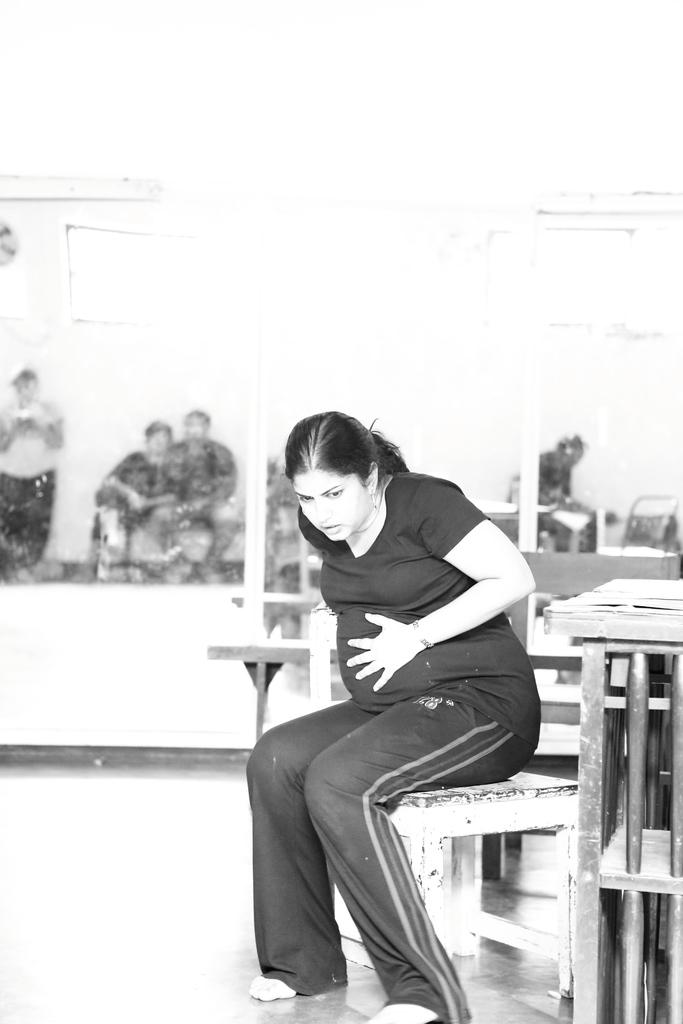Who is the main subject in the image? There is a woman in the image. What is the woman doing in the image? The woman is sitting in a chair. Where is the woman located in relation to the table? The woman is in front of a table. What can be seen in the background of the image? There is a glass in the background of the image, and people are visible through it. What are the people doing in the image? Some of the people are sitting, while others are standing. What type of books can be seen on the table in the image? There are no books visible on the table in the image. 